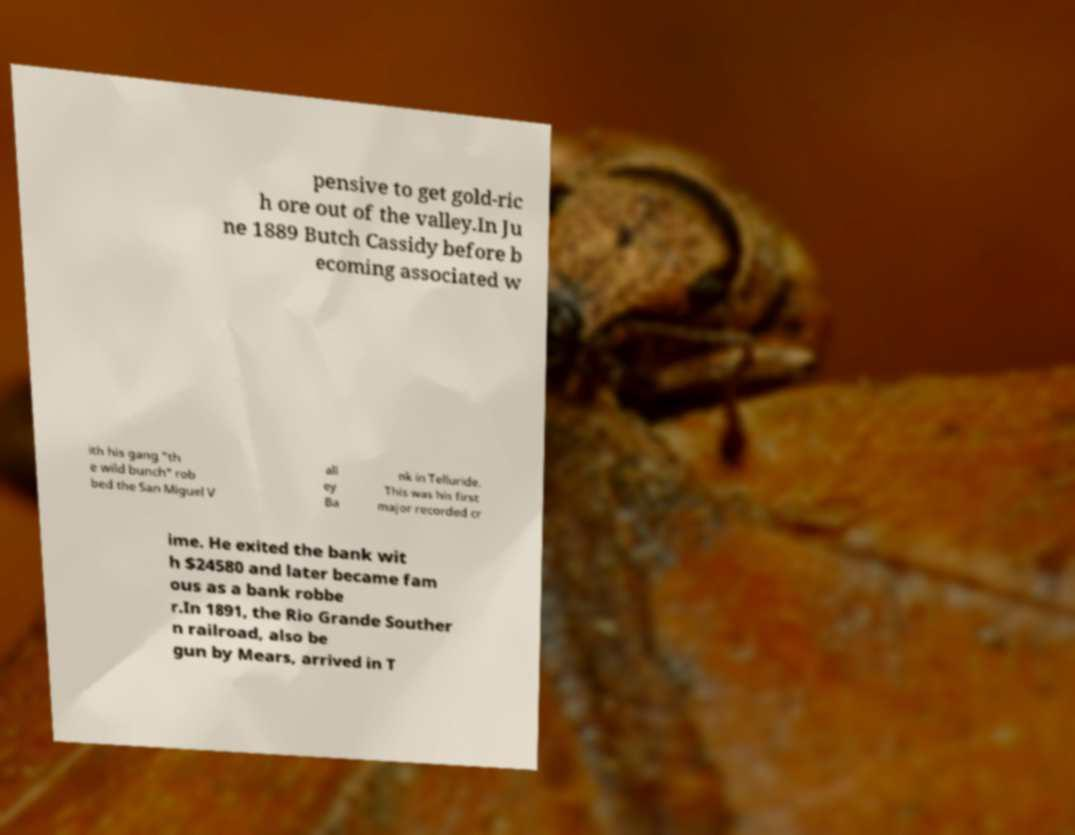Can you accurately transcribe the text from the provided image for me? pensive to get gold-ric h ore out of the valley.In Ju ne 1889 Butch Cassidy before b ecoming associated w ith his gang "th e wild bunch" rob bed the San Miguel V all ey Ba nk in Telluride. This was his first major recorded cr ime. He exited the bank wit h $24580 and later became fam ous as a bank robbe r.In 1891, the Rio Grande Souther n railroad, also be gun by Mears, arrived in T 